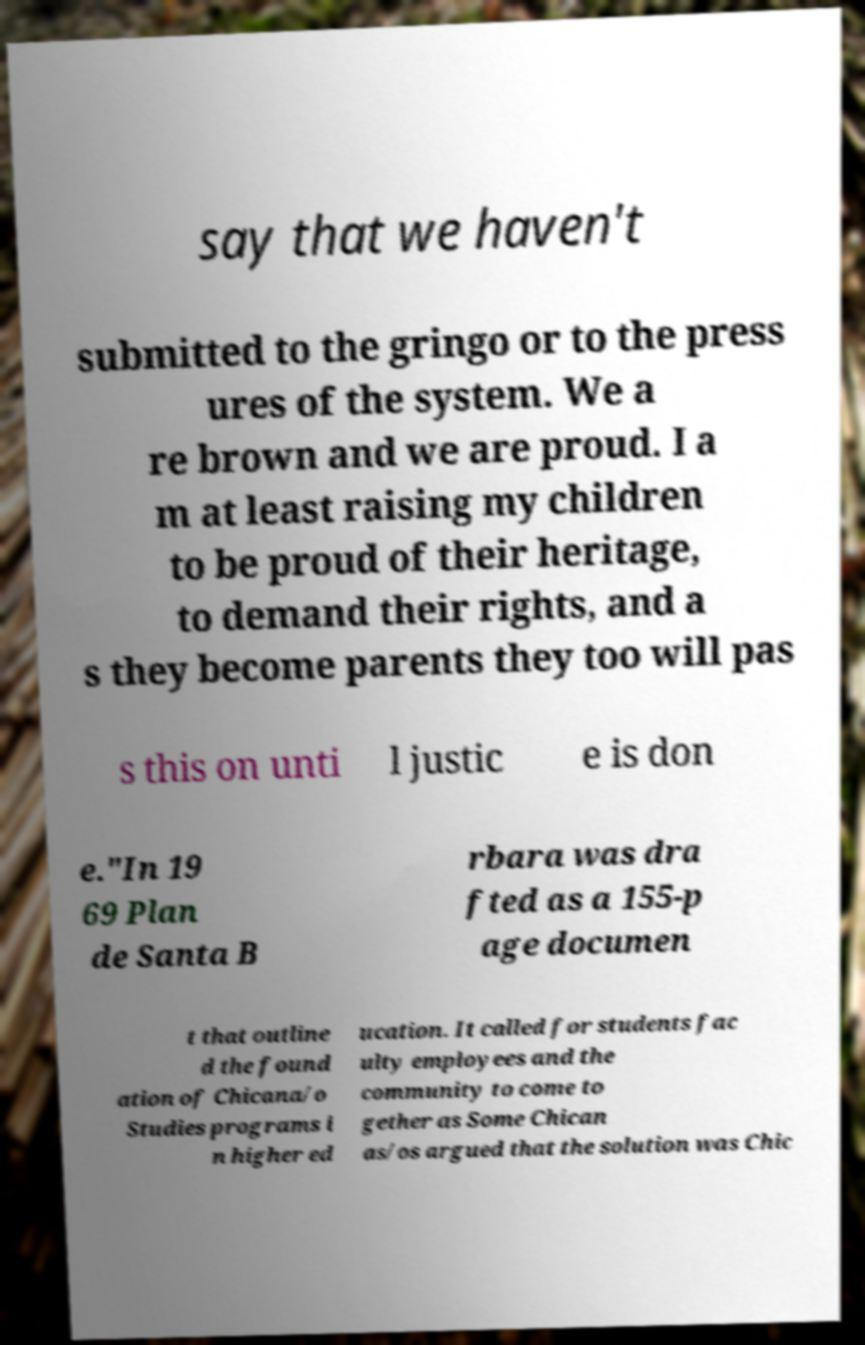There's text embedded in this image that I need extracted. Can you transcribe it verbatim? say that we haven't submitted to the gringo or to the press ures of the system. We a re brown and we are proud. I a m at least raising my children to be proud of their heritage, to demand their rights, and a s they become parents they too will pas s this on unti l justic e is don e."In 19 69 Plan de Santa B rbara was dra fted as a 155-p age documen t that outline d the found ation of Chicana/o Studies programs i n higher ed ucation. It called for students fac ulty employees and the community to come to gether as Some Chican as/os argued that the solution was Chic 